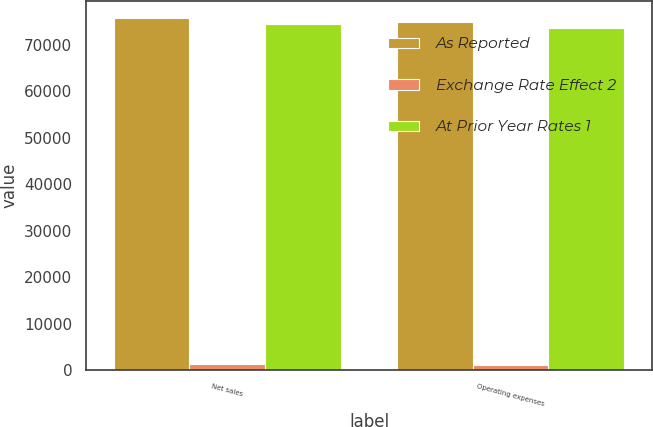<chart> <loc_0><loc_0><loc_500><loc_500><stacked_bar_chart><ecel><fcel>Net sales<fcel>Operating expenses<nl><fcel>As Reported<fcel>75736<fcel>74962<nl><fcel>Exchange Rate Effect 2<fcel>1284<fcel>1255<nl><fcel>At Prior Year Rates 1<fcel>74452<fcel>73707<nl></chart> 